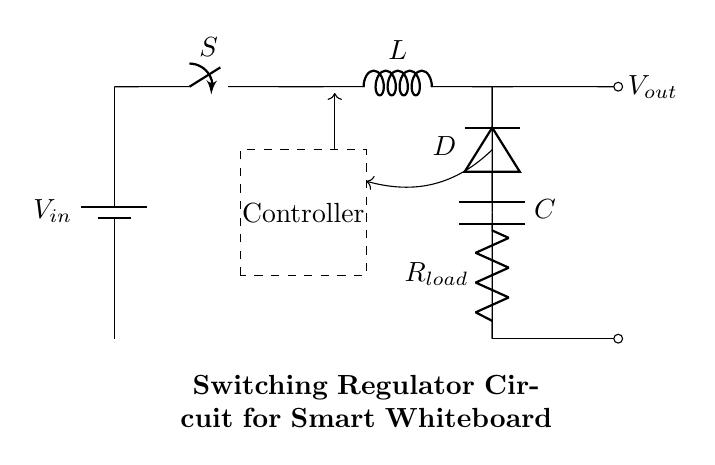What is the input source of the circuit? The input source is a battery, designated as V in, which provides the necessary voltage to the circuit.
Answer: Battery What component is used to store energy in this circuit? The component storing energy in this switching regulator circuit is the inductor labeled as L. It temporarily stores energy in the magnetic field during the on phase of the switching cycle.
Answer: Inductor What is the purpose of the diode in this circuit? The diode, labeled as D, allows current to flow in only one direction, preventing backflow which helps maintain output voltage during the off phase of the switch.
Answer: Prevents backflow What is the function of the capacitor in this circuit? The capacitor labeled as C smooths the output voltage by filtering out voltage ripples, ensuring a steady output to the load.
Answer: Smoothing voltage How does the controller affect the operation of this regulator? The controller regulates the switch's operation based on the feedback it receives, adjusting the duty cycle to maintain the desired output voltage despite variations in input voltage or load conditions.
Answer: Regulates switching What type of regulator is illustrated in this circuit? This circuit is a switching regulator, which is designed to efficiently manage power by alternating between connecting and disconnecting the load from the power source.
Answer: Switching regulator What component provides the load in the circuit? The load in this circuit is represented by the resistor labeled as R load, which consumes the power provided by the regulator.
Answer: Resistor 